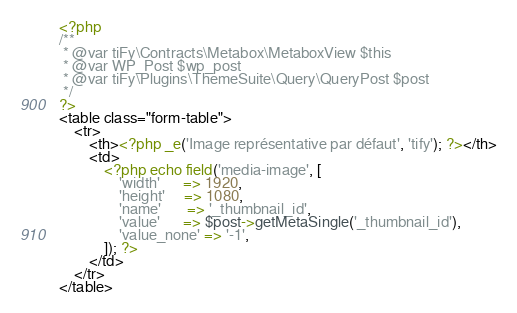Convert code to text. <code><loc_0><loc_0><loc_500><loc_500><_PHP_><?php
/**
 * @var tiFy\Contracts\Metabox\MetaboxView $this
 * @var WP_Post $wp_post
 * @var tiFy\Plugins\ThemeSuite\Query\QueryPost $post
 */
?>
<table class="form-table">
    <tr>
        <th><?php _e('Image représentative par défaut', 'tify'); ?></th>
        <td>
            <?php echo field('media-image', [
                'width'      => 1920,
                'height'     => 1080,
                'name'       => '_thumbnail_id',
                'value'      => $post->getMetaSingle('_thumbnail_id'),
                'value_none' => '-1',
            ]); ?>
        </td>
    </tr>
</table>
</code> 